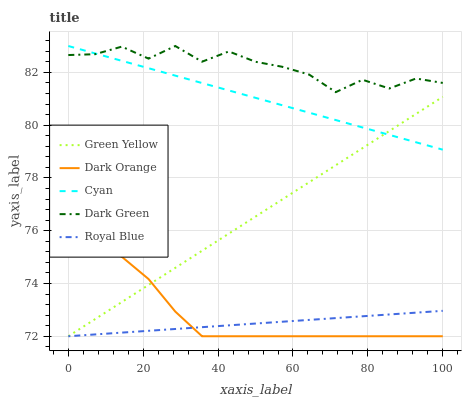Does Royal Blue have the minimum area under the curve?
Answer yes or no. Yes. Does Dark Green have the maximum area under the curve?
Answer yes or no. Yes. Does Green Yellow have the minimum area under the curve?
Answer yes or no. No. Does Green Yellow have the maximum area under the curve?
Answer yes or no. No. Is Green Yellow the smoothest?
Answer yes or no. Yes. Is Dark Green the roughest?
Answer yes or no. Yes. Is Dark Green the smoothest?
Answer yes or no. No. Is Green Yellow the roughest?
Answer yes or no. No. Does Dark Orange have the lowest value?
Answer yes or no. Yes. Does Dark Green have the lowest value?
Answer yes or no. No. Does Cyan have the highest value?
Answer yes or no. Yes. Does Green Yellow have the highest value?
Answer yes or no. No. Is Royal Blue less than Cyan?
Answer yes or no. Yes. Is Dark Green greater than Royal Blue?
Answer yes or no. Yes. Does Dark Orange intersect Royal Blue?
Answer yes or no. Yes. Is Dark Orange less than Royal Blue?
Answer yes or no. No. Is Dark Orange greater than Royal Blue?
Answer yes or no. No. Does Royal Blue intersect Cyan?
Answer yes or no. No. 